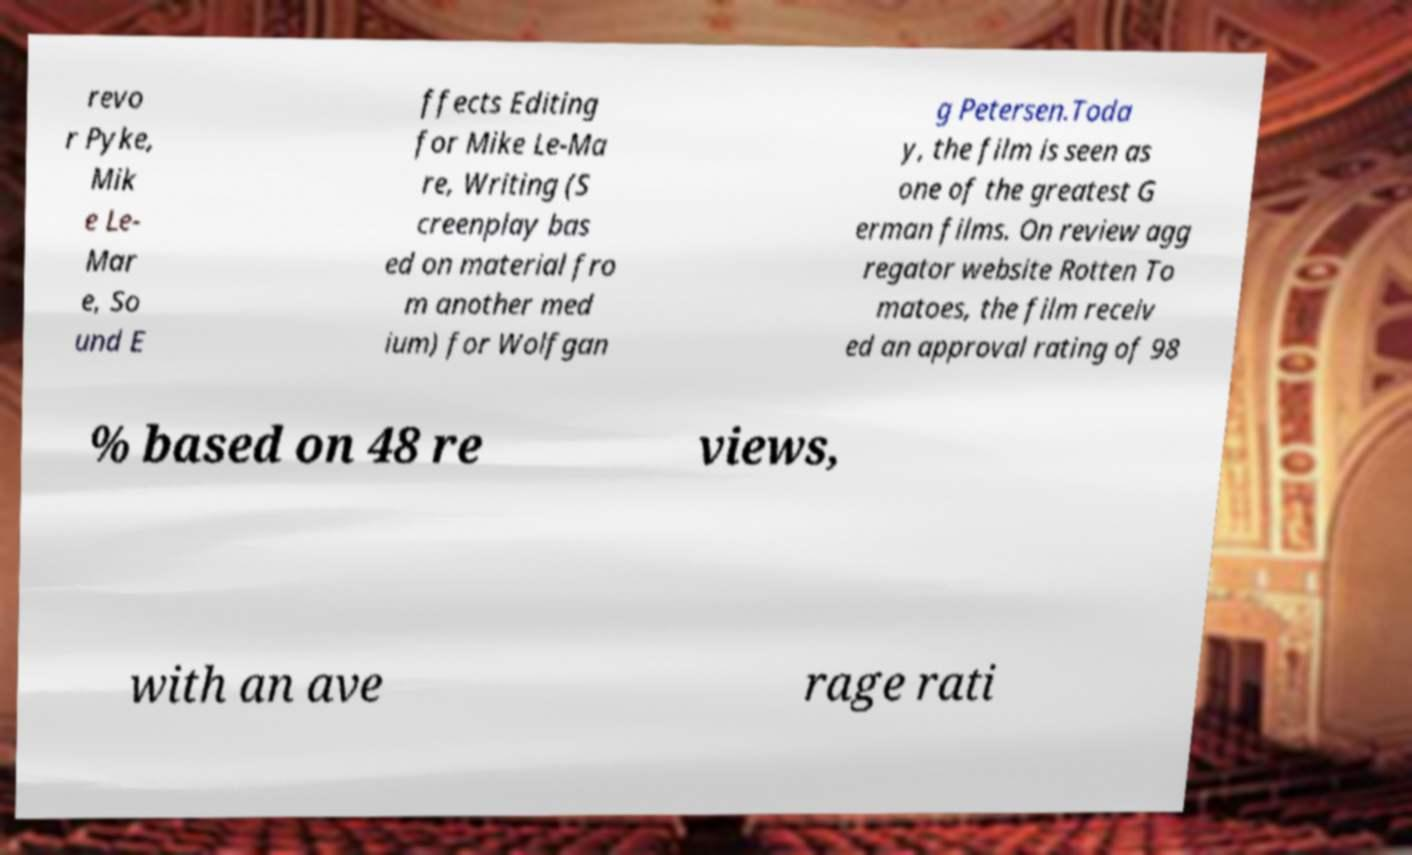What messages or text are displayed in this image? I need them in a readable, typed format. revo r Pyke, Mik e Le- Mar e, So und E ffects Editing for Mike Le-Ma re, Writing (S creenplay bas ed on material fro m another med ium) for Wolfgan g Petersen.Toda y, the film is seen as one of the greatest G erman films. On review agg regator website Rotten To matoes, the film receiv ed an approval rating of 98 % based on 48 re views, with an ave rage rati 